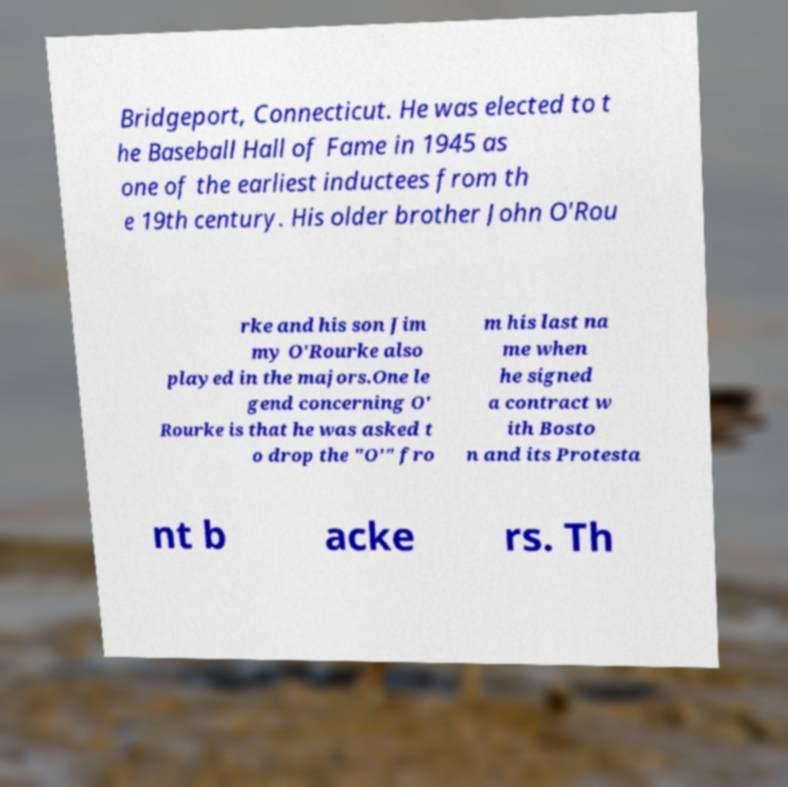Please read and relay the text visible in this image. What does it say? Bridgeport, Connecticut. He was elected to t he Baseball Hall of Fame in 1945 as one of the earliest inductees from th e 19th century. His older brother John O'Rou rke and his son Jim my O'Rourke also played in the majors.One le gend concerning O' Rourke is that he was asked t o drop the "O'" fro m his last na me when he signed a contract w ith Bosto n and its Protesta nt b acke rs. Th 